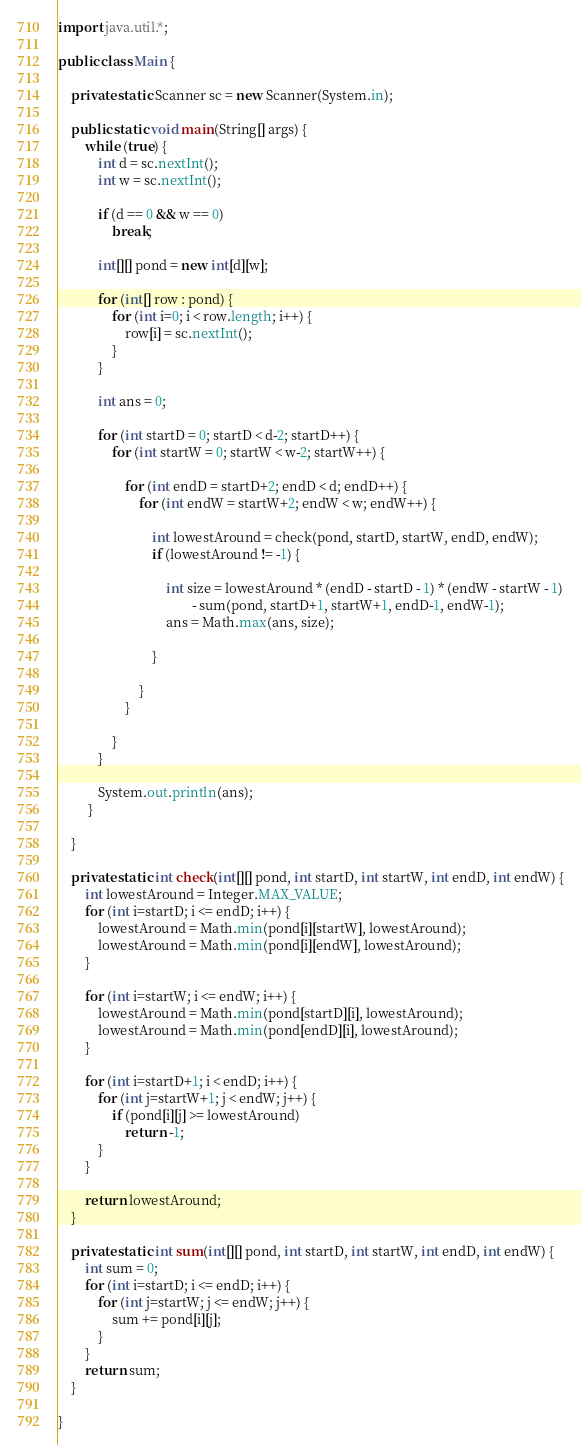Convert code to text. <code><loc_0><loc_0><loc_500><loc_500><_Java_>import java.util.*;

public class Main {

    private static Scanner sc = new Scanner(System.in);

    public static void main(String[] args) {
        while (true) {
            int d = sc.nextInt();
            int w = sc.nextInt();

            if (d == 0 && w == 0)
                break;

            int[][] pond = new int[d][w];

            for (int[] row : pond) {
                for (int i=0; i < row.length; i++) {
                    row[i] = sc.nextInt();
                }
            }

            int ans = 0;

            for (int startD = 0; startD < d-2; startD++) {
                for (int startW = 0; startW < w-2; startW++) {

                    for (int endD = startD+2; endD < d; endD++) {
                        for (int endW = startW+2; endW < w; endW++) {

                            int lowestAround = check(pond, startD, startW, endD, endW);
                            if (lowestAround != -1) {

                                int size = lowestAround * (endD - startD - 1) * (endW - startW - 1)
                                        - sum(pond, startD+1, startW+1, endD-1, endW-1);
                                ans = Math.max(ans, size);

                            }

                        }
                    }

                }
            }

            System.out.println(ans);
         }

    }

    private static int check(int[][] pond, int startD, int startW, int endD, int endW) {
        int lowestAround = Integer.MAX_VALUE;
        for (int i=startD; i <= endD; i++) {
            lowestAround = Math.min(pond[i][startW], lowestAround);
            lowestAround = Math.min(pond[i][endW], lowestAround);
        }
        
        for (int i=startW; i <= endW; i++) {
            lowestAround = Math.min(pond[startD][i], lowestAround);
            lowestAround = Math.min(pond[endD][i], lowestAround);
        }

        for (int i=startD+1; i < endD; i++) {
            for (int j=startW+1; j < endW; j++) {
                if (pond[i][j] >= lowestAround)
                    return -1;
            }
        }

        return lowestAround;
    }

    private static int sum(int[][] pond, int startD, int startW, int endD, int endW) {
        int sum = 0;
        for (int i=startD; i <= endD; i++) {
            for (int j=startW; j <= endW; j++) {
                sum += pond[i][j];
            }
        }
        return sum;
    }

}

</code> 